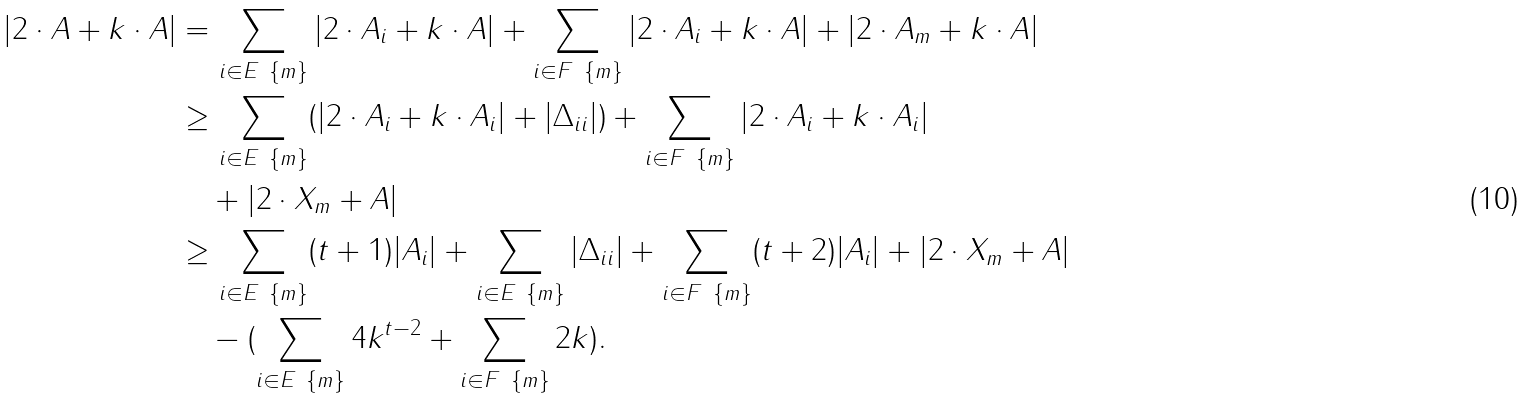<formula> <loc_0><loc_0><loc_500><loc_500>| 2 \cdot A + k \cdot A | & = \sum _ { i \in E \ \{ m \} } | 2 \cdot A _ { i } + k \cdot A | + \sum _ { i \in F \ \{ m \} } | 2 \cdot A _ { i } + k \cdot A | + | 2 \cdot A _ { m } + k \cdot A | \\ & \geq \sum _ { i \in E \ \{ m \} } ( | 2 \cdot A _ { i } + k \cdot A _ { i } | + | \Delta _ { i i } | ) + \sum _ { i \in F \ \{ m \} } | 2 \cdot A _ { i } + k \cdot A _ { i } | \\ & \quad + | 2 \cdot X _ { m } + A | \\ & \geq \sum _ { i \in E \ \{ m \} } ( t + 1 ) | A _ { i } | + \sum _ { i \in E \ \{ m \} } | \Delta _ { i i } | + \sum _ { i \in F \ \{ m \} } ( t + 2 ) | A _ { i } | + | 2 \cdot X _ { m } + A | \\ & \quad - ( \sum _ { i \in E \ \{ m \} } 4 k ^ { t - 2 } + \sum _ { i \in F \ \{ m \} } 2 k ) .</formula> 